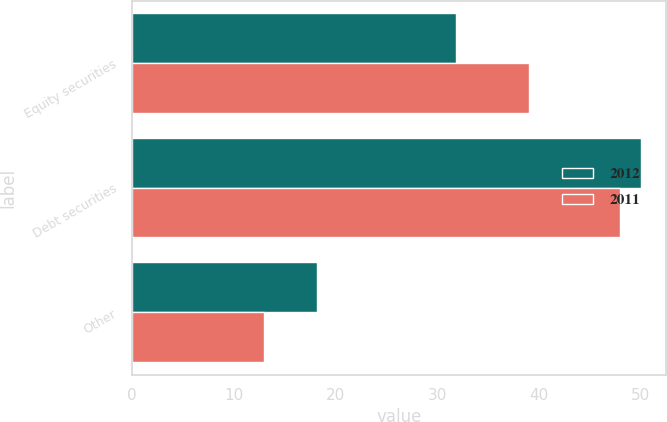Convert chart. <chart><loc_0><loc_0><loc_500><loc_500><stacked_bar_chart><ecel><fcel>Equity securities<fcel>Debt securities<fcel>Other<nl><fcel>2012<fcel>31.8<fcel>50<fcel>18.2<nl><fcel>2011<fcel>39<fcel>48<fcel>13<nl></chart> 